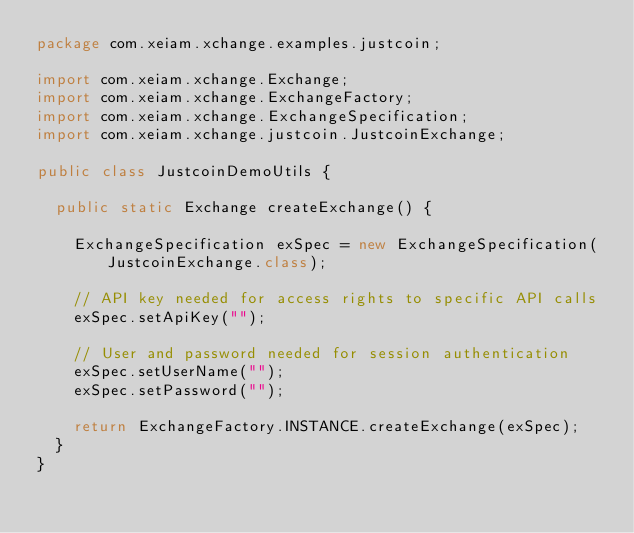Convert code to text. <code><loc_0><loc_0><loc_500><loc_500><_Java_>package com.xeiam.xchange.examples.justcoin;

import com.xeiam.xchange.Exchange;
import com.xeiam.xchange.ExchangeFactory;
import com.xeiam.xchange.ExchangeSpecification;
import com.xeiam.xchange.justcoin.JustcoinExchange;

public class JustcoinDemoUtils {

  public static Exchange createExchange() {

    ExchangeSpecification exSpec = new ExchangeSpecification(JustcoinExchange.class);

    // API key needed for access rights to specific API calls
    exSpec.setApiKey("");

    // User and password needed for session authentication
    exSpec.setUserName("");
    exSpec.setPassword("");

    return ExchangeFactory.INSTANCE.createExchange(exSpec);
  }
}
</code> 